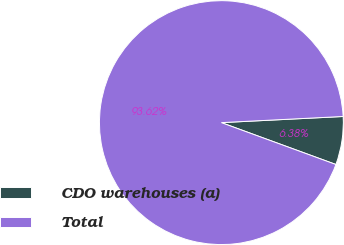Convert chart. <chart><loc_0><loc_0><loc_500><loc_500><pie_chart><fcel>CDO warehouses (a)<fcel>Total<nl><fcel>6.38%<fcel>93.62%<nl></chart> 